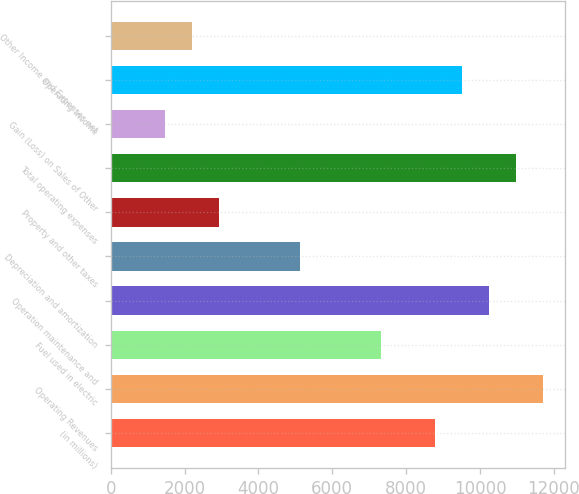<chart> <loc_0><loc_0><loc_500><loc_500><bar_chart><fcel>(in millions)<fcel>Operating Revenues<fcel>Fuel used in electric<fcel>Operation maintenance and<fcel>Depreciation and amortization<fcel>Property and other taxes<fcel>Total operating expenses<fcel>Gain (Loss) on Sales of Other<fcel>Operating Income<fcel>Other Income and Expenses net<nl><fcel>8786<fcel>11714<fcel>7322<fcel>10250<fcel>5126<fcel>2930<fcel>10982<fcel>1466<fcel>9518<fcel>2198<nl></chart> 